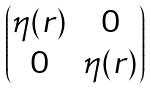Convert formula to latex. <formula><loc_0><loc_0><loc_500><loc_500>\begin{pmatrix} \eta ( r ) & 0 \\ 0 & \eta ( r ) \end{pmatrix}</formula> 